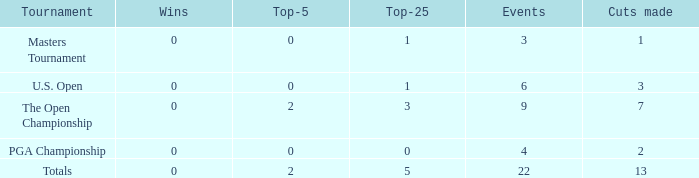How many cumulative cuts occurred in events that had greater than 0 wins and no top-5 finishes? 0.0. 